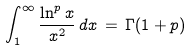<formula> <loc_0><loc_0><loc_500><loc_500>\int _ { 1 } ^ { \infty } \frac { \ln ^ { p } x } { x ^ { 2 } } \, d x \, = \, \Gamma ( 1 + p )</formula> 